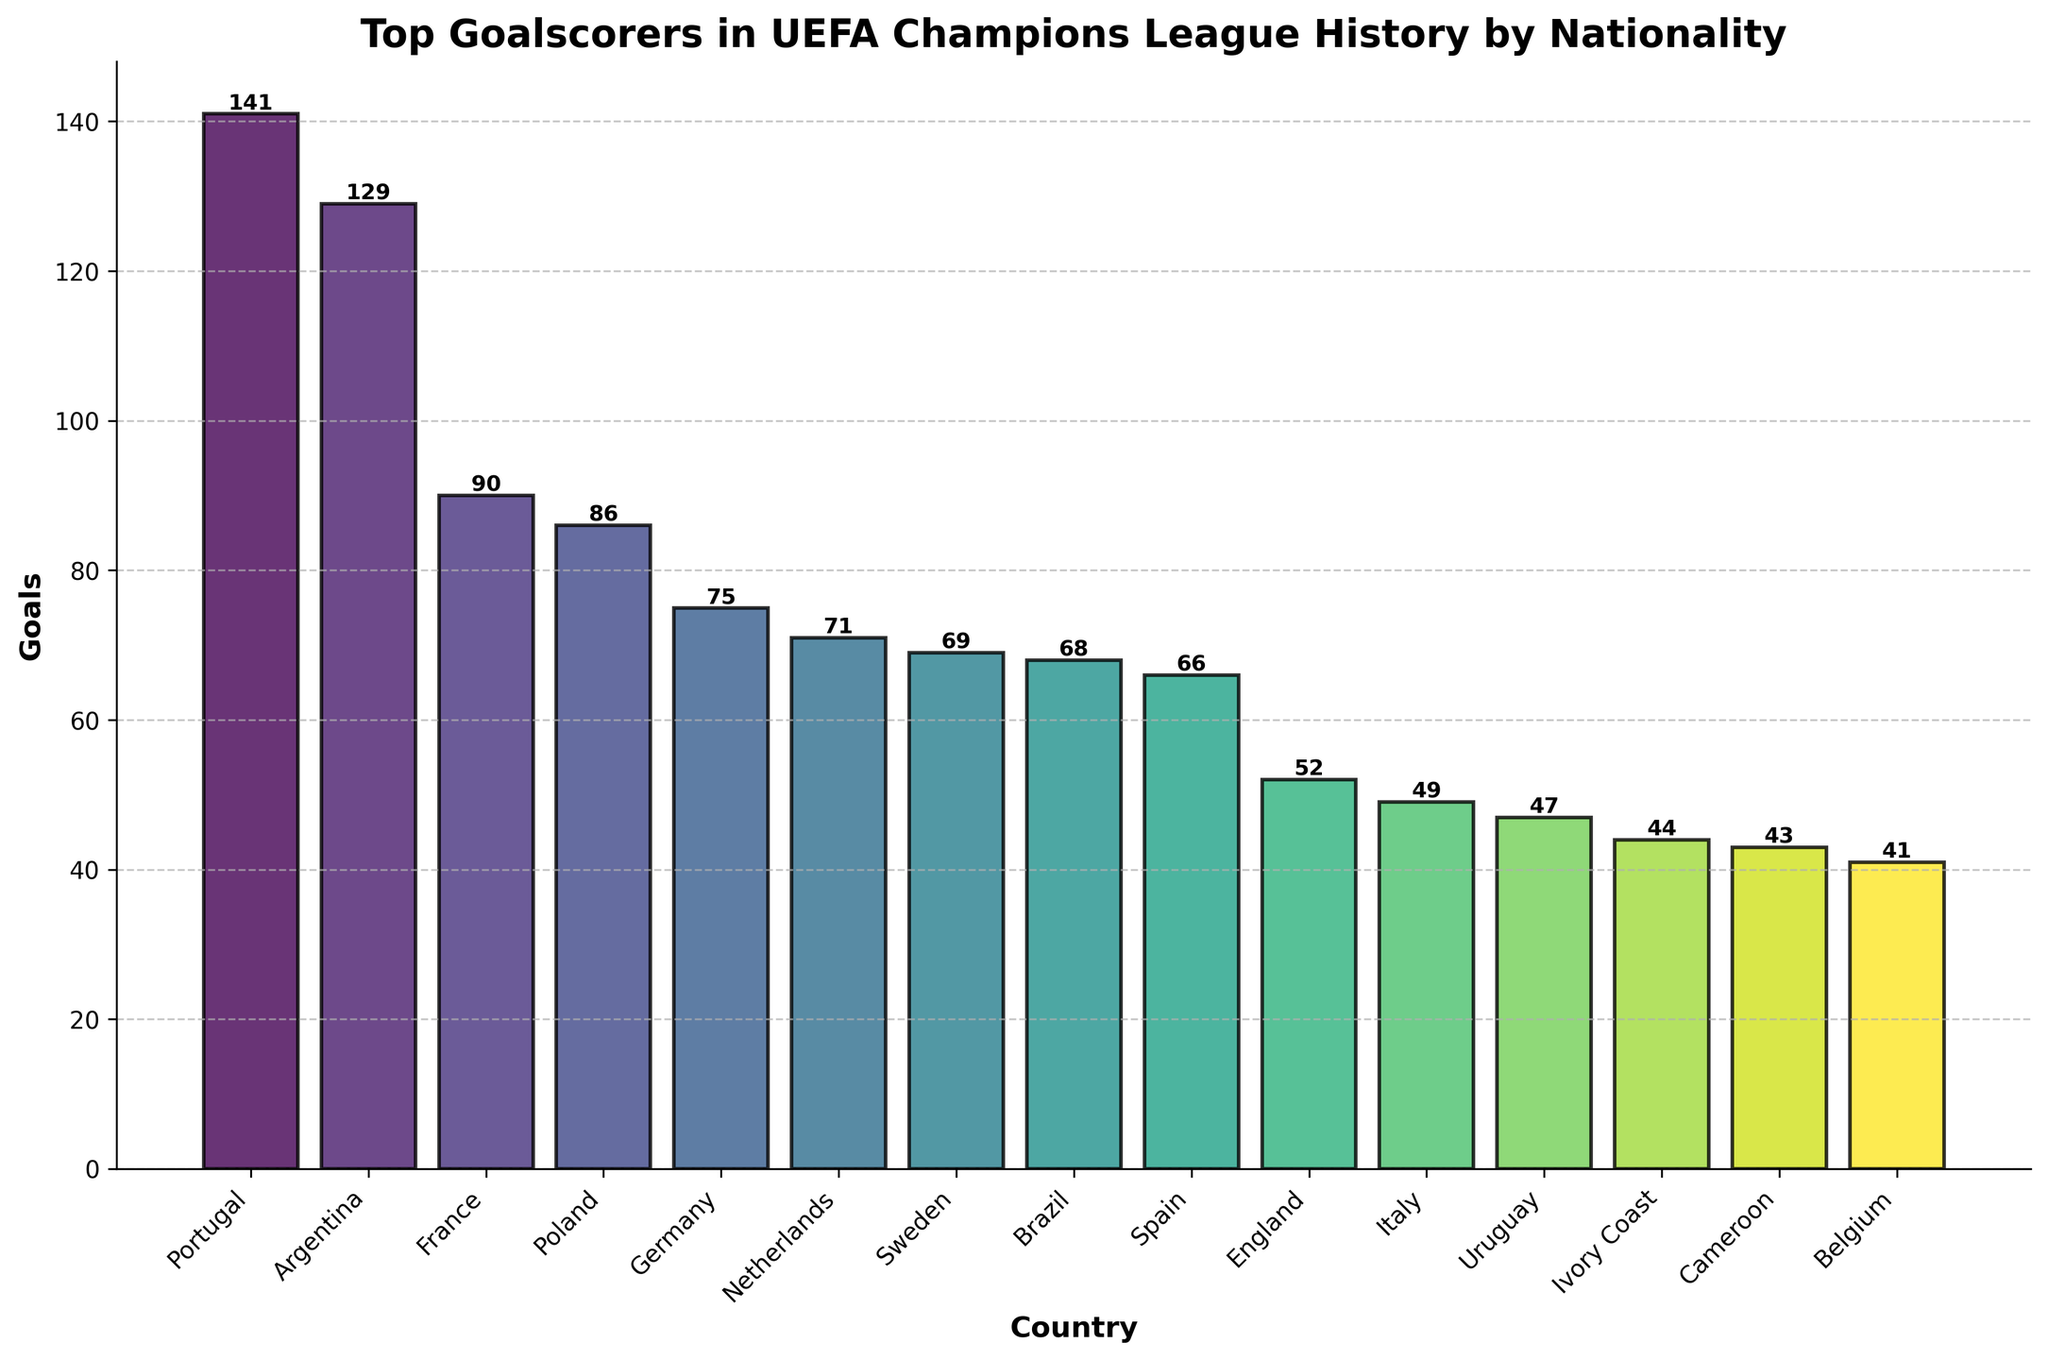Which country has the highest number of goalscorers? According to the bar chart, the country with the tallest bar represents the highest number of goalscorers. By observing the chart, Portugal has the highest bar with 141 goals.
Answer: Portugal What is the difference in goals between Germany and Netherlands? From the chart, Germany has 75 goals, and the Netherlands has 71 goals. Subtracting these values gives the difference: 75 - 71 = 4.
Answer: 4 How many total goals have been scored by players from the top 3 countries combined? The top 3 countries by number of goals are Portugal (141), Argentina (129), and France (90). Adding these values together, we get 141 + 129 + 90 = 360.
Answer: 360 Which country has scored more goals, Brazil or Spain? Checking the chart, Brazil has 68 goals, while Spain has 66. Since 68 is greater than 66, Brazil has scored more goals.
Answer: Brazil What is the average number of goals scored by Italy, Uruguay, and Ivory Coast? Italy has 49 goals, Uruguay has 47, and the Ivory Coast has 44. Adding these and dividing by the number of countries: (49 + 47 + 44) / 3 = 140 / 3 ≈ 46.67.
Answer: 46.67 Is the number of goals scored by England closer to Spain or to Brazil? England has 52 goals. Spain has 66 goals, and the difference is 66 - 52 = 14. Brazil has 68 goals, and the difference is 68 - 52 = 16. Since 14 is less than 16, England’s goals are closer to Spain's total.
Answer: Spain What is the median number of goals scored among all listed countries? To find the median, list the number of goals in order: 41, 43, 44, 47, 49, 52, 66, 68, 69, 71, 75, 86, 90, 129, 141. The median is the middle value in this ordered list. Since there are 15 countries, the 8th value is the median, which is 68 goals (Brazil).
Answer: 68 What is the combined number of goals scored by countries with less than 50 goals? The countries with less than 50 goals are Ivory Coast (44), Cameroon (43), Belgium (41), and Italy (49). Adding these together, 44 + 43 + 41 + 49 = 177.
Answer: 177 How many more goals has Poland scored compared to Sweden? From the chart, Poland has 86 goals while Sweden has 69. Subtracting these: 86 - 69 = 17.
Answer: 17 Which country's bar is directly in the middle of the chart when ordered by a number of goals from highest to lowest? There are 15 countries, and the one in the middle (the 8th country) is Brazil with 68 goals as per the ordered list: Portugal, Argentina, France, Poland, Germany, Netherlands, Sweden, Brazil, Spain, England, Italy, Uruguay, Ivory Coast, Cameroon, Belgium.
Answer: Brazil 